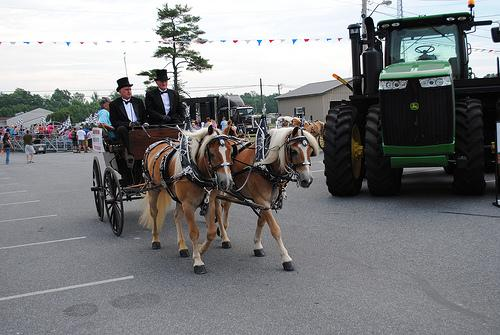Identify the type of vehicle parked in the lot. A green John Deere tractor is parked in the lot. Describe the banner in the image. There is a blue, red, and white pennant banner. What are the type of pants worn by a person standing in the parking lot? The person is wearing blue pants. What key feature can be found on the tractor? A John Deere logo is on the tractor. How many wheels can be seen on one side of the carriage? Two wheels can be seen on one side of the carriage. Mention a detail about the horses' appearance. The horses have long white hair and black harnesses. What is the color and style of the men's outfits on the carriage? The men are wearing tuxedos and top hats. What is the appearance of the tree in the image? There is a large tree with green leaves. What are two men wearing on their heads? Two men are wearing black top hats on their heads. Explain the scene involving horses. Two brown horses are pulling a carriage with two men in tuxedos driving it, and one of the men is wearing a light blue shirt. Mention the color of the carriage. Brown Create a sentence about the image that incorporates the green tractor and the horses. A green John Deere tractor is parked nearby while two brown horses pull a carriage with two men in suits and top hats. What type of tractor is parked in the lot? Green John Deere tractor Are there any white and pink flags hanging from the blue, red, and white pennant banner? There is no mention of any white and pink flags hanging from the banner, which is described as a blue, red, and white pennant banner in the image. How many wheels are there on one side of the buggy? Two wheels Can you see a rocket ship in the sky above the green tractor? There is no mention of a rocket ship or anything related to it in the sky above the tractor in the image. Notice the tree in the image and describe its appearance. Large tree with green leaves Mention an activity taking place in the image. Two men driving a carriage Describe the appearance of the man riding in the carriage. Man in a light blue shirt What does the white sign on the side of the buggy say? OCR is unable to determine Spot a line of flags and mention their colors. Line of black and white flags Provide an overview of the image, including key objects and activities. Two men in suits and top hats riding a carriage pulled by horses, with a green tractor in the background, all surrounded by flags. What are the men in the carriage wearing?  Suits and top hats Identify an event happening in the picture. Horses pulling a buggy Is the man wearing pink shorts and standing near the green tractor? There is no mention of a man with pink shorts near the green tractor in the image. Are there chickens walking around next to the man in a light blue shirt riding in the carriage? There is no mention of any chickens in the image, either walking around or related to the man in the light blue shirt. Is there a giant octopus crawling out of the tree with green leaves? There is no mention of any octopus in the image, let alone a giant one crawling out of a tree. What is on the heads of the two men riding the carriage? Two black top hats What is the brand of the green tractor? John Deere What are the two animals pulling the carriage? Two brown horses Are the horses in the picture blue and pink, galloping across a field? The image describes brown horses pulling a carriage on a road, not galloping in a field, and there are no mentions of blue or pink horses. Choose the correct caption for the object with top hats: a) two men wearing top hats, b) two men wearing cowboy hats, c) two men wearing helmets. a) two men wearing top hats What activity are the horses engaged in? Pulling a carriage Identify a decoration in the image involving multiple colors. Blue, red, and white pennant banner Describe a distinct feature of the tractor's front end. Headlights in the front of the tractor 